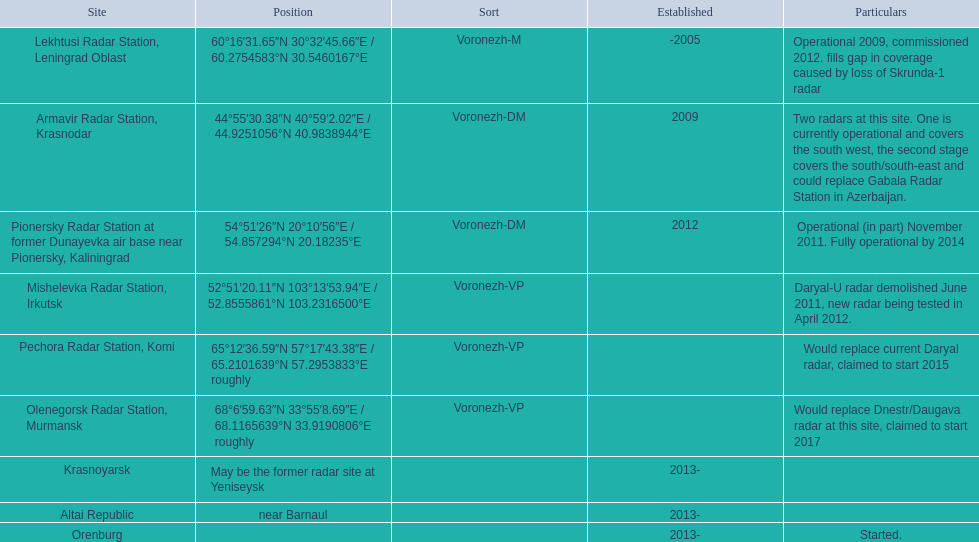What are all of the locations? Lekhtusi Radar Station, Leningrad Oblast, Armavir Radar Station, Krasnodar, Pionersky Radar Station at former Dunayevka air base near Pionersky, Kaliningrad, Mishelevka Radar Station, Irkutsk, Pechora Radar Station, Komi, Olenegorsk Radar Station, Murmansk, Krasnoyarsk, Altai Republic, Orenburg. And which location's coordinates are 60deg16'31.65''n 30deg32'45.66''e / 60.2754583degn 30.5460167dege? Lekhtusi Radar Station, Leningrad Oblast. 